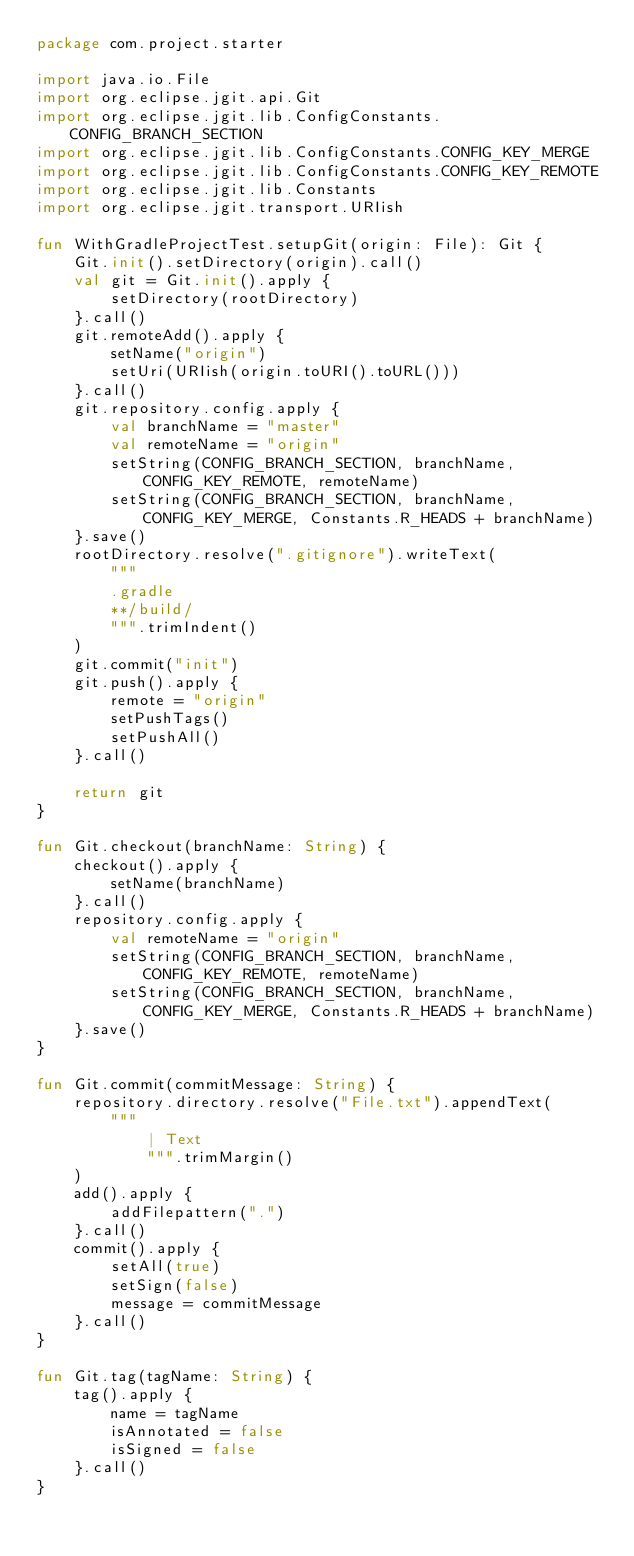<code> <loc_0><loc_0><loc_500><loc_500><_Kotlin_>package com.project.starter

import java.io.File
import org.eclipse.jgit.api.Git
import org.eclipse.jgit.lib.ConfigConstants.CONFIG_BRANCH_SECTION
import org.eclipse.jgit.lib.ConfigConstants.CONFIG_KEY_MERGE
import org.eclipse.jgit.lib.ConfigConstants.CONFIG_KEY_REMOTE
import org.eclipse.jgit.lib.Constants
import org.eclipse.jgit.transport.URIish

fun WithGradleProjectTest.setupGit(origin: File): Git {
    Git.init().setDirectory(origin).call()
    val git = Git.init().apply {
        setDirectory(rootDirectory)
    }.call()
    git.remoteAdd().apply {
        setName("origin")
        setUri(URIish(origin.toURI().toURL()))
    }.call()
    git.repository.config.apply {
        val branchName = "master"
        val remoteName = "origin"
        setString(CONFIG_BRANCH_SECTION, branchName, CONFIG_KEY_REMOTE, remoteName)
        setString(CONFIG_BRANCH_SECTION, branchName, CONFIG_KEY_MERGE, Constants.R_HEADS + branchName)
    }.save()
    rootDirectory.resolve(".gitignore").writeText(
        """
        .gradle
        **/build/
        """.trimIndent()
    )
    git.commit("init")
    git.push().apply {
        remote = "origin"
        setPushTags()
        setPushAll()
    }.call()

    return git
}

fun Git.checkout(branchName: String) {
    checkout().apply {
        setName(branchName)
    }.call()
    repository.config.apply {
        val remoteName = "origin"
        setString(CONFIG_BRANCH_SECTION, branchName, CONFIG_KEY_REMOTE, remoteName)
        setString(CONFIG_BRANCH_SECTION, branchName, CONFIG_KEY_MERGE, Constants.R_HEADS + branchName)
    }.save()
}

fun Git.commit(commitMessage: String) {
    repository.directory.resolve("File.txt").appendText(
        """
            | Text
            """.trimMargin()
    )
    add().apply {
        addFilepattern(".")
    }.call()
    commit().apply {
        setAll(true)
        setSign(false)
        message = commitMessage
    }.call()
}

fun Git.tag(tagName: String) {
    tag().apply {
        name = tagName
        isAnnotated = false
        isSigned = false
    }.call()
}
</code> 